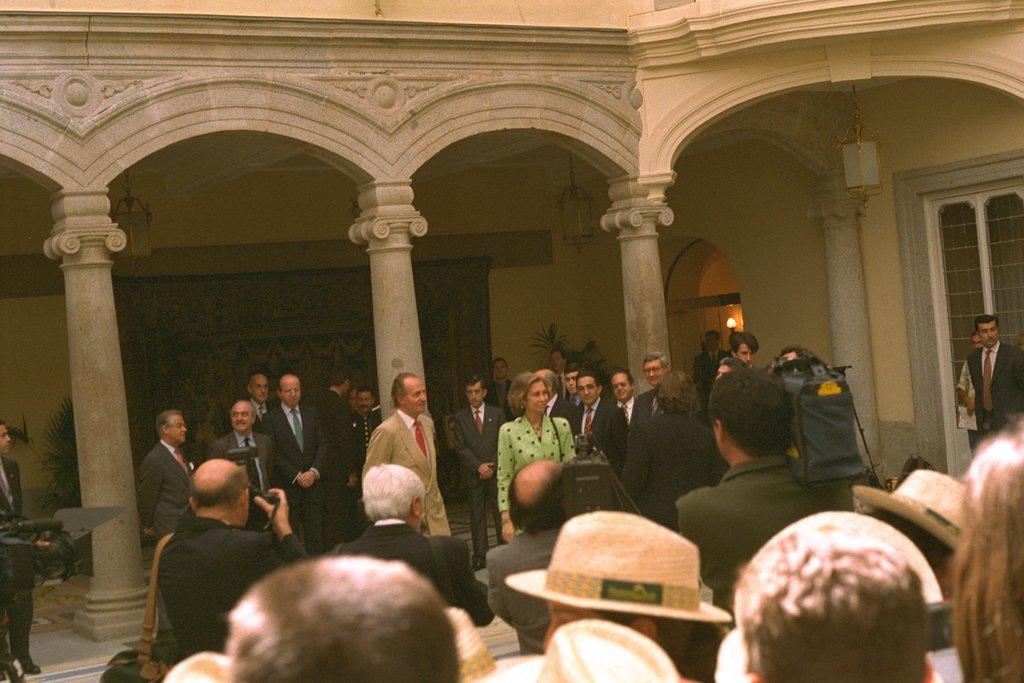Could you give a brief overview of what you see in this image? In this image we can see men and women are standing. There are pillars in the background and lights are attached to the roof. We can see a window on the right side of the image and some plants in the background. 